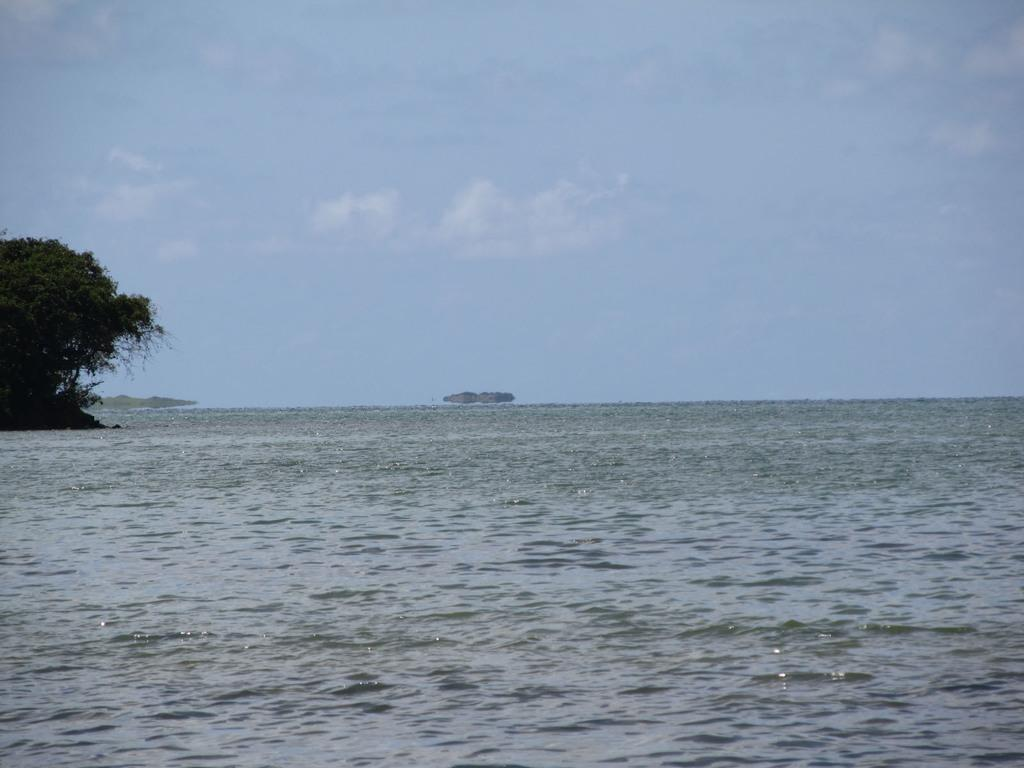What type of natural body of water is present in the image? There is a sea in the image. What can be seen in the background of the image? There are trees in the background of the image. What is the color of the trees? The trees are green. What is visible above the sea and trees in the image? The sky is visible in the image. What colors can be seen in the sky? The sky is blue and white in color. What type of metal is the kitty using to crack the egg in the image? There is no kitty or egg present in the image, and therefore no such activity can be observed. 